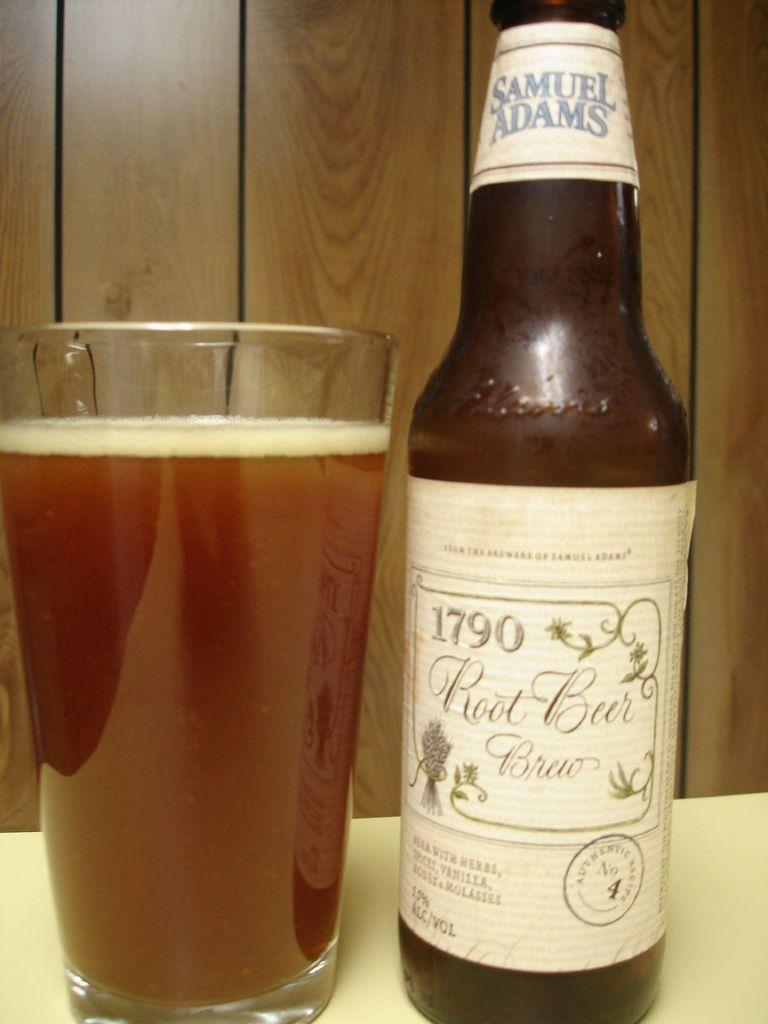<image>
Offer a succinct explanation of the picture presented. A Samuel Adams beer bottle next to a glass filled with the beer. 